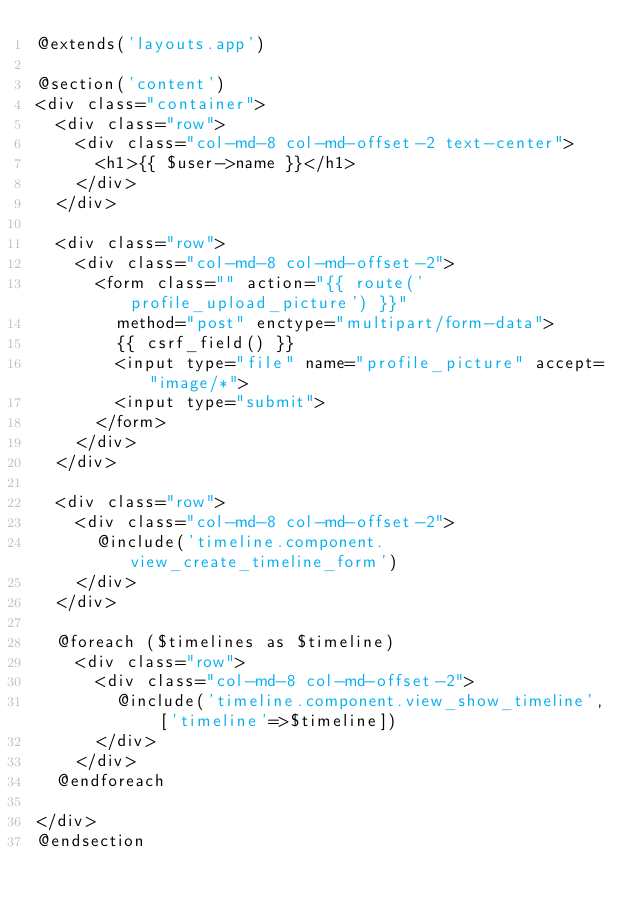<code> <loc_0><loc_0><loc_500><loc_500><_PHP_>@extends('layouts.app')

@section('content')
<div class="container">
  <div class="row">
    <div class="col-md-8 col-md-offset-2 text-center">
      <h1>{{ $user->name }}</h1>
    </div>
  </div>

  <div class="row">
    <div class="col-md-8 col-md-offset-2">
      <form class="" action="{{ route('profile_upload_picture') }}"
        method="post" enctype="multipart/form-data">
        {{ csrf_field() }}
        <input type="file" name="profile_picture" accept="image/*">
        <input type="submit">
      </form>
    </div>
  </div>

  <div class="row">
    <div class="col-md-8 col-md-offset-2">
      @include('timeline.component.view_create_timeline_form')
    </div>
  </div>

  @foreach ($timelines as $timeline)
    <div class="row">
      <div class="col-md-8 col-md-offset-2">
        @include('timeline.component.view_show_timeline', ['timeline'=>$timeline])
      </div>
    </div>
  @endforeach

</div>
@endsection
</code> 